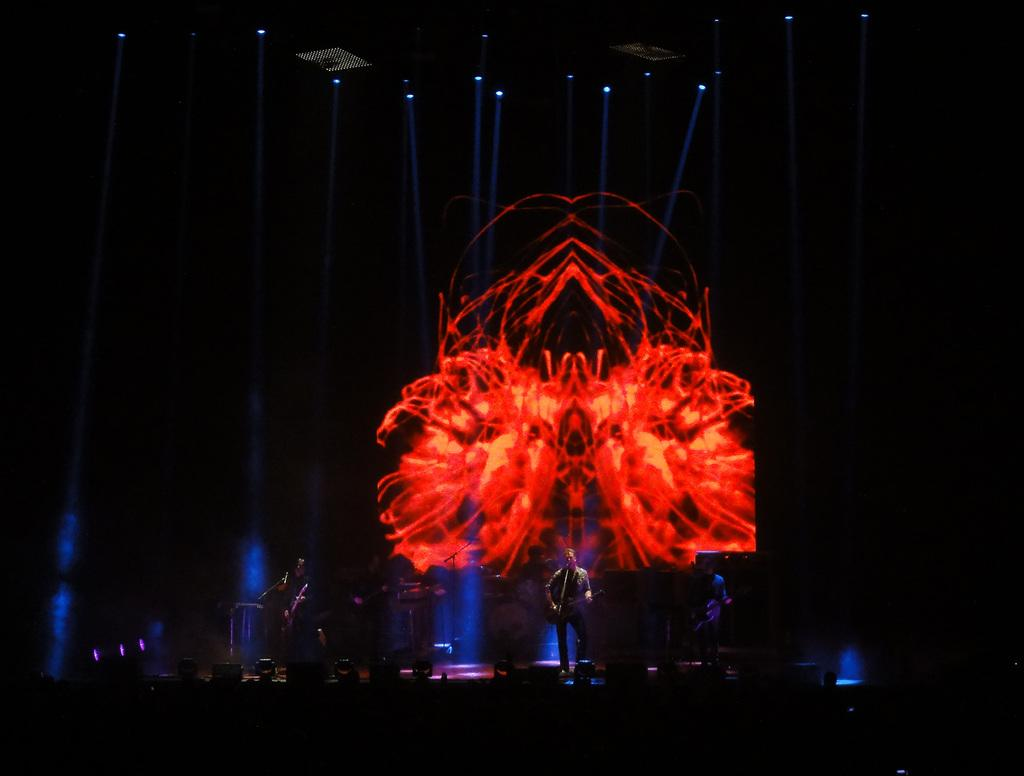What are the persons in the image doing? The persons in the image are playing musical instruments. Where are the musical instruments located in the image? The musical instruments are at the bottom of the image. What can be seen at the top of the image? There are lights visible at the top of the image. What type of good-bye message is written on the oven in the image? There is no oven present in the image, and therefore no good-bye message can be observed. 